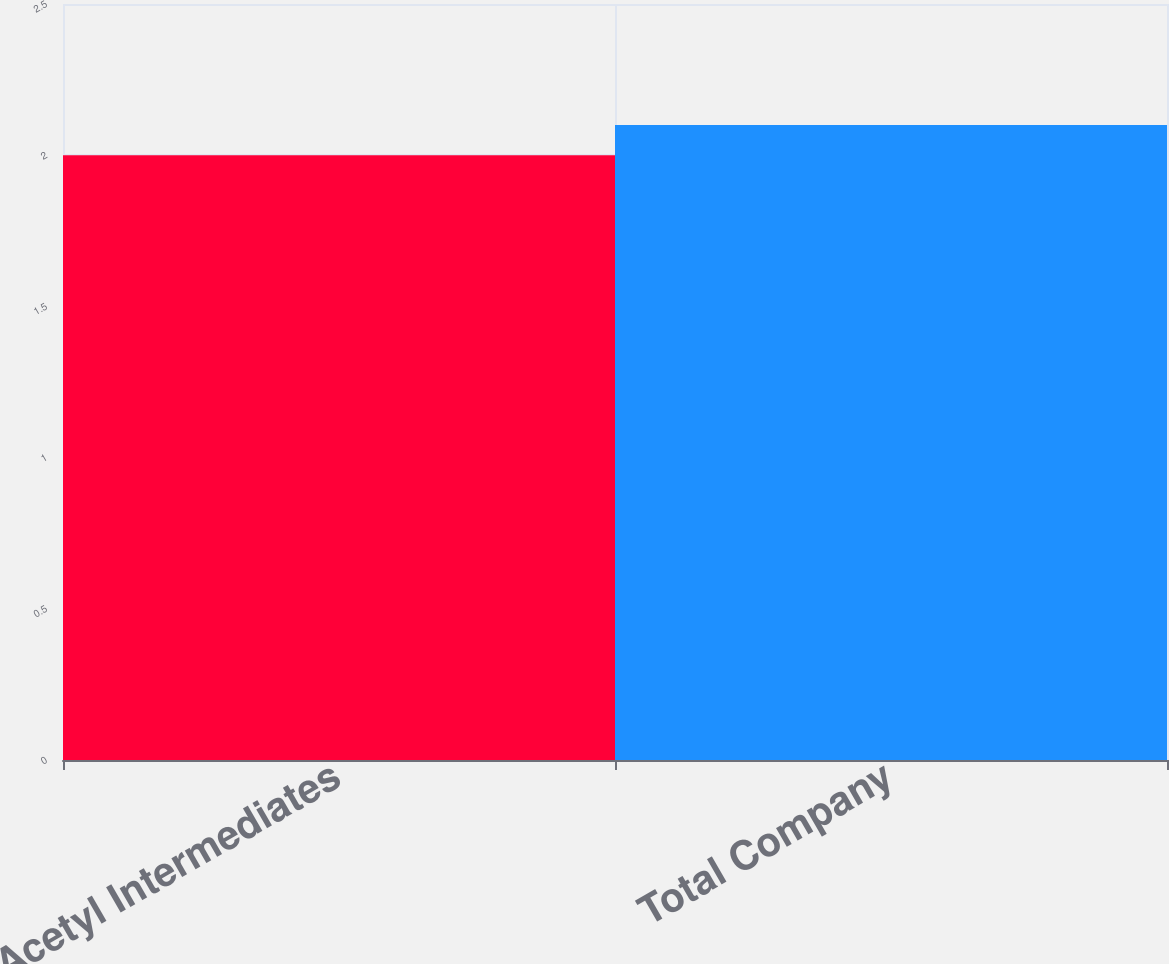Convert chart to OTSL. <chart><loc_0><loc_0><loc_500><loc_500><bar_chart><fcel>Acetyl Intermediates<fcel>Total Company<nl><fcel>2<fcel>2.1<nl></chart> 